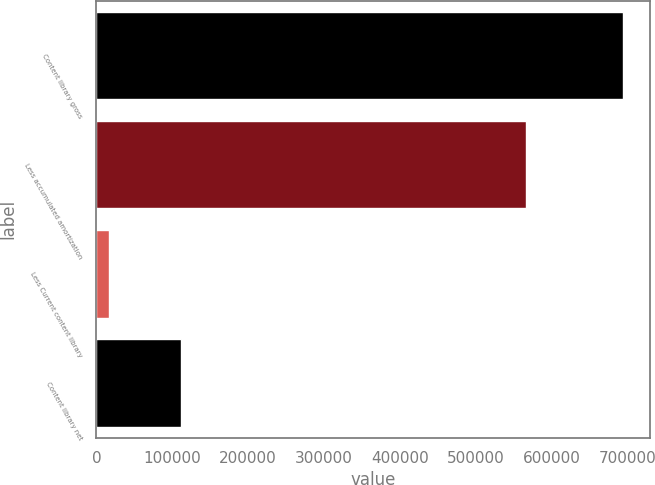<chart> <loc_0><loc_0><loc_500><loc_500><bar_chart><fcel>Content library gross<fcel>Less accumulated amortization<fcel>Less Current content library<fcel>Content library net<nl><fcel>694620<fcel>566249<fcel>16301<fcel>112070<nl></chart> 